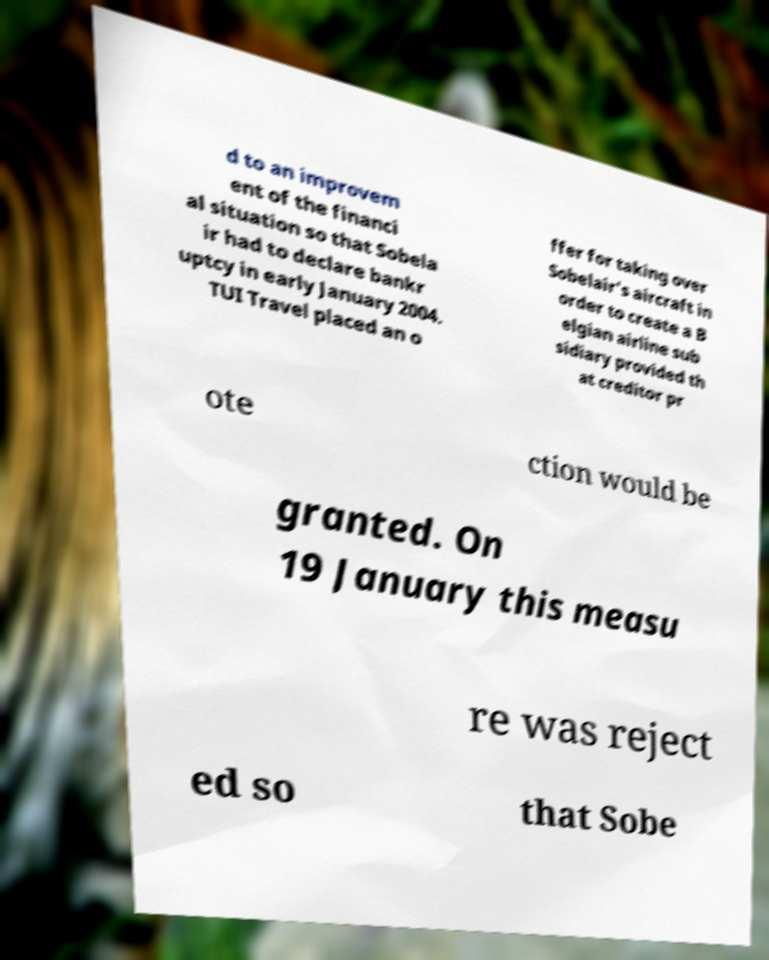There's text embedded in this image that I need extracted. Can you transcribe it verbatim? d to an improvem ent of the financi al situation so that Sobela ir had to declare bankr uptcy in early January 2004. TUI Travel placed an o ffer for taking over Sobelair's aircraft in order to create a B elgian airline sub sidiary provided th at creditor pr ote ction would be granted. On 19 January this measu re was reject ed so that Sobe 